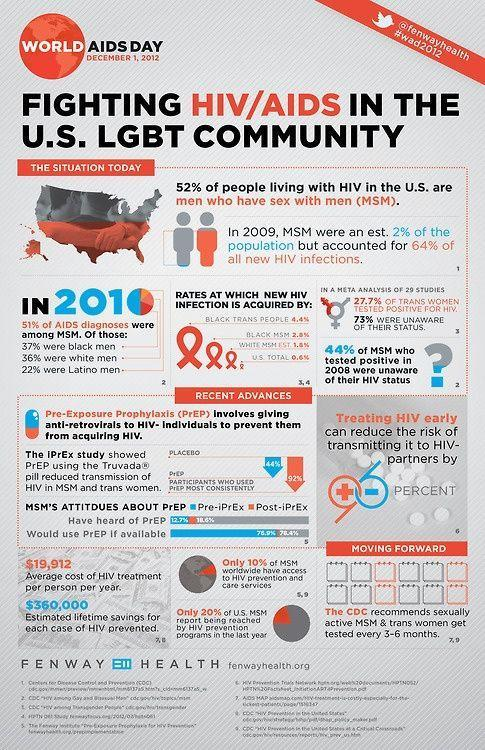what percentage of MSM do not have access to HIV prevention and care services
Answer the question with a short phrase. 90 what was the total percentage of white men and latino men diagnosed with AIDS 58 who has recommended tests every 3-6 months CDC what is the average cost of HIV treatment per person per year $19,912 by how much percentage can early treatment of HIV prevent transmission 96 